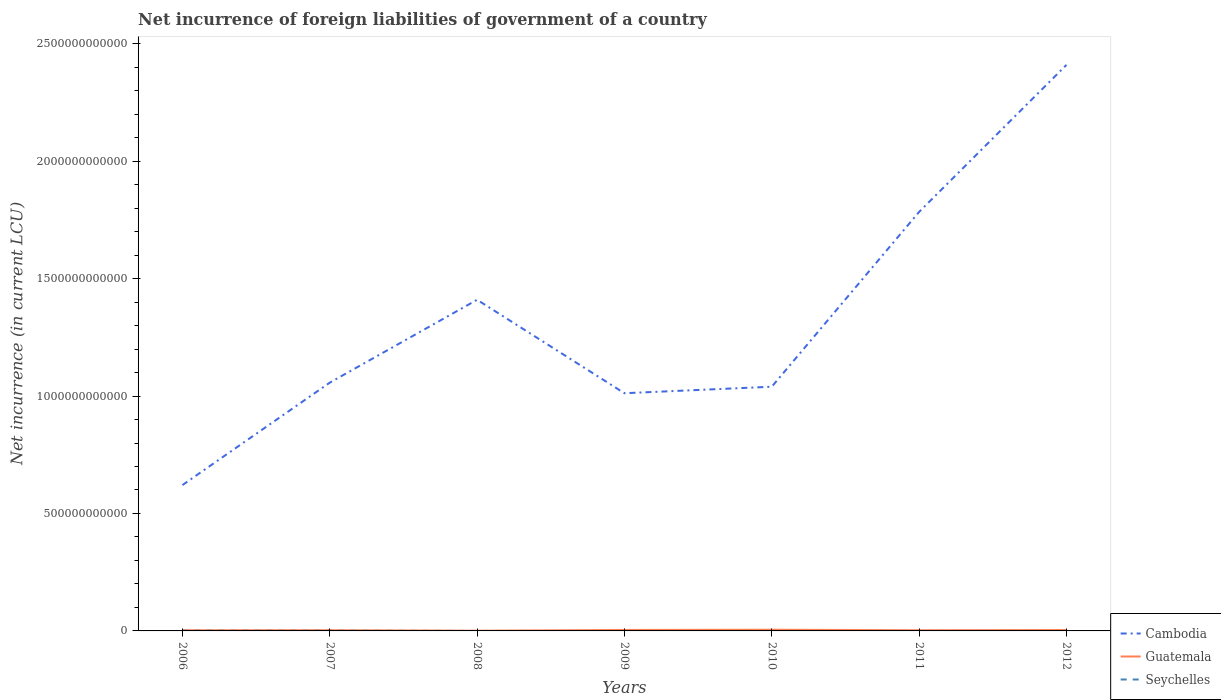How many different coloured lines are there?
Give a very brief answer. 3. Does the line corresponding to Guatemala intersect with the line corresponding to Cambodia?
Make the answer very short. No. What is the total net incurrence of foreign liabilities in Guatemala in the graph?
Give a very brief answer. -2.95e+09. What is the difference between the highest and the second highest net incurrence of foreign liabilities in Cambodia?
Give a very brief answer. 1.79e+12. What is the difference between the highest and the lowest net incurrence of foreign liabilities in Seychelles?
Your response must be concise. 2. What is the difference between two consecutive major ticks on the Y-axis?
Ensure brevity in your answer.  5.00e+11. Are the values on the major ticks of Y-axis written in scientific E-notation?
Keep it short and to the point. No. Where does the legend appear in the graph?
Your answer should be very brief. Bottom right. What is the title of the graph?
Offer a terse response. Net incurrence of foreign liabilities of government of a country. Does "Qatar" appear as one of the legend labels in the graph?
Give a very brief answer. No. What is the label or title of the X-axis?
Provide a succinct answer. Years. What is the label or title of the Y-axis?
Provide a short and direct response. Net incurrence (in current LCU). What is the Net incurrence (in current LCU) of Cambodia in 2006?
Provide a succinct answer. 6.21e+11. What is the Net incurrence (in current LCU) in Guatemala in 2006?
Provide a succinct answer. 2.87e+09. What is the Net incurrence (in current LCU) of Seychelles in 2006?
Your response must be concise. 8.78e+08. What is the Net incurrence (in current LCU) of Cambodia in 2007?
Your answer should be very brief. 1.06e+12. What is the Net incurrence (in current LCU) of Guatemala in 2007?
Offer a terse response. 3.04e+09. What is the Net incurrence (in current LCU) of Seychelles in 2007?
Your answer should be very brief. 7.25e+08. What is the Net incurrence (in current LCU) of Cambodia in 2008?
Offer a very short reply. 1.41e+12. What is the Net incurrence (in current LCU) of Guatemala in 2008?
Provide a short and direct response. 8.50e+08. What is the Net incurrence (in current LCU) of Seychelles in 2008?
Ensure brevity in your answer.  0. What is the Net incurrence (in current LCU) of Cambodia in 2009?
Keep it short and to the point. 1.01e+12. What is the Net incurrence (in current LCU) in Guatemala in 2009?
Make the answer very short. 4.12e+09. What is the Net incurrence (in current LCU) of Cambodia in 2010?
Offer a very short reply. 1.04e+12. What is the Net incurrence (in current LCU) in Guatemala in 2010?
Provide a succinct answer. 5.11e+09. What is the Net incurrence (in current LCU) of Seychelles in 2010?
Offer a very short reply. 0. What is the Net incurrence (in current LCU) of Cambodia in 2011?
Keep it short and to the point. 1.78e+12. What is the Net incurrence (in current LCU) of Guatemala in 2011?
Keep it short and to the point. 2.92e+09. What is the Net incurrence (in current LCU) of Cambodia in 2012?
Ensure brevity in your answer.  2.41e+12. What is the Net incurrence (in current LCU) of Guatemala in 2012?
Offer a terse response. 3.80e+09. Across all years, what is the maximum Net incurrence (in current LCU) of Cambodia?
Give a very brief answer. 2.41e+12. Across all years, what is the maximum Net incurrence (in current LCU) in Guatemala?
Your answer should be compact. 5.11e+09. Across all years, what is the maximum Net incurrence (in current LCU) in Seychelles?
Provide a succinct answer. 8.78e+08. Across all years, what is the minimum Net incurrence (in current LCU) in Cambodia?
Your response must be concise. 6.21e+11. Across all years, what is the minimum Net incurrence (in current LCU) in Guatemala?
Keep it short and to the point. 8.50e+08. What is the total Net incurrence (in current LCU) of Cambodia in the graph?
Provide a succinct answer. 9.33e+12. What is the total Net incurrence (in current LCU) in Guatemala in the graph?
Keep it short and to the point. 2.27e+1. What is the total Net incurrence (in current LCU) of Seychelles in the graph?
Provide a succinct answer. 1.60e+09. What is the difference between the Net incurrence (in current LCU) in Cambodia in 2006 and that in 2007?
Make the answer very short. -4.36e+11. What is the difference between the Net incurrence (in current LCU) of Guatemala in 2006 and that in 2007?
Make the answer very short. -1.74e+08. What is the difference between the Net incurrence (in current LCU) in Seychelles in 2006 and that in 2007?
Make the answer very short. 1.54e+08. What is the difference between the Net incurrence (in current LCU) of Cambodia in 2006 and that in 2008?
Offer a terse response. -7.89e+11. What is the difference between the Net incurrence (in current LCU) of Guatemala in 2006 and that in 2008?
Make the answer very short. 2.02e+09. What is the difference between the Net incurrence (in current LCU) of Cambodia in 2006 and that in 2009?
Give a very brief answer. -3.91e+11. What is the difference between the Net incurrence (in current LCU) of Guatemala in 2006 and that in 2009?
Your answer should be compact. -1.25e+09. What is the difference between the Net incurrence (in current LCU) of Cambodia in 2006 and that in 2010?
Your answer should be compact. -4.19e+11. What is the difference between the Net incurrence (in current LCU) of Guatemala in 2006 and that in 2010?
Provide a short and direct response. -2.24e+09. What is the difference between the Net incurrence (in current LCU) in Cambodia in 2006 and that in 2011?
Make the answer very short. -1.16e+12. What is the difference between the Net incurrence (in current LCU) in Guatemala in 2006 and that in 2011?
Offer a terse response. -5.65e+07. What is the difference between the Net incurrence (in current LCU) in Cambodia in 2006 and that in 2012?
Provide a short and direct response. -1.79e+12. What is the difference between the Net incurrence (in current LCU) in Guatemala in 2006 and that in 2012?
Offer a terse response. -9.31e+08. What is the difference between the Net incurrence (in current LCU) of Cambodia in 2007 and that in 2008?
Provide a short and direct response. -3.53e+11. What is the difference between the Net incurrence (in current LCU) in Guatemala in 2007 and that in 2008?
Your answer should be very brief. 2.19e+09. What is the difference between the Net incurrence (in current LCU) of Cambodia in 2007 and that in 2009?
Make the answer very short. 4.50e+1. What is the difference between the Net incurrence (in current LCU) in Guatemala in 2007 and that in 2009?
Offer a very short reply. -1.08e+09. What is the difference between the Net incurrence (in current LCU) of Cambodia in 2007 and that in 2010?
Your answer should be very brief. 1.73e+1. What is the difference between the Net incurrence (in current LCU) in Guatemala in 2007 and that in 2010?
Provide a succinct answer. -2.07e+09. What is the difference between the Net incurrence (in current LCU) in Cambodia in 2007 and that in 2011?
Make the answer very short. -7.27e+11. What is the difference between the Net incurrence (in current LCU) in Guatemala in 2007 and that in 2011?
Your response must be concise. 1.17e+08. What is the difference between the Net incurrence (in current LCU) of Cambodia in 2007 and that in 2012?
Offer a very short reply. -1.35e+12. What is the difference between the Net incurrence (in current LCU) of Guatemala in 2007 and that in 2012?
Provide a short and direct response. -7.57e+08. What is the difference between the Net incurrence (in current LCU) in Cambodia in 2008 and that in 2009?
Make the answer very short. 3.98e+11. What is the difference between the Net incurrence (in current LCU) in Guatemala in 2008 and that in 2009?
Your answer should be compact. -3.27e+09. What is the difference between the Net incurrence (in current LCU) in Cambodia in 2008 and that in 2010?
Your response must be concise. 3.70e+11. What is the difference between the Net incurrence (in current LCU) of Guatemala in 2008 and that in 2010?
Your response must be concise. -4.26e+09. What is the difference between the Net incurrence (in current LCU) of Cambodia in 2008 and that in 2011?
Provide a succinct answer. -3.74e+11. What is the difference between the Net incurrence (in current LCU) in Guatemala in 2008 and that in 2011?
Offer a terse response. -2.07e+09. What is the difference between the Net incurrence (in current LCU) in Cambodia in 2008 and that in 2012?
Provide a succinct answer. -1.00e+12. What is the difference between the Net incurrence (in current LCU) of Guatemala in 2008 and that in 2012?
Give a very brief answer. -2.95e+09. What is the difference between the Net incurrence (in current LCU) of Cambodia in 2009 and that in 2010?
Offer a very short reply. -2.77e+1. What is the difference between the Net incurrence (in current LCU) of Guatemala in 2009 and that in 2010?
Your answer should be compact. -9.92e+08. What is the difference between the Net incurrence (in current LCU) of Cambodia in 2009 and that in 2011?
Make the answer very short. -7.72e+11. What is the difference between the Net incurrence (in current LCU) of Guatemala in 2009 and that in 2011?
Your response must be concise. 1.19e+09. What is the difference between the Net incurrence (in current LCU) of Cambodia in 2009 and that in 2012?
Your answer should be compact. -1.40e+12. What is the difference between the Net incurrence (in current LCU) in Guatemala in 2009 and that in 2012?
Your response must be concise. 3.20e+08. What is the difference between the Net incurrence (in current LCU) in Cambodia in 2010 and that in 2011?
Offer a terse response. -7.44e+11. What is the difference between the Net incurrence (in current LCU) in Guatemala in 2010 and that in 2011?
Provide a succinct answer. 2.19e+09. What is the difference between the Net incurrence (in current LCU) in Cambodia in 2010 and that in 2012?
Offer a very short reply. -1.37e+12. What is the difference between the Net incurrence (in current LCU) of Guatemala in 2010 and that in 2012?
Ensure brevity in your answer.  1.31e+09. What is the difference between the Net incurrence (in current LCU) in Cambodia in 2011 and that in 2012?
Give a very brief answer. -6.26e+11. What is the difference between the Net incurrence (in current LCU) of Guatemala in 2011 and that in 2012?
Provide a succinct answer. -8.74e+08. What is the difference between the Net incurrence (in current LCU) of Cambodia in 2006 and the Net incurrence (in current LCU) of Guatemala in 2007?
Offer a terse response. 6.18e+11. What is the difference between the Net incurrence (in current LCU) in Cambodia in 2006 and the Net incurrence (in current LCU) in Seychelles in 2007?
Your response must be concise. 6.20e+11. What is the difference between the Net incurrence (in current LCU) of Guatemala in 2006 and the Net incurrence (in current LCU) of Seychelles in 2007?
Your answer should be very brief. 2.14e+09. What is the difference between the Net incurrence (in current LCU) in Cambodia in 2006 and the Net incurrence (in current LCU) in Guatemala in 2008?
Keep it short and to the point. 6.20e+11. What is the difference between the Net incurrence (in current LCU) in Cambodia in 2006 and the Net incurrence (in current LCU) in Guatemala in 2009?
Provide a short and direct response. 6.17e+11. What is the difference between the Net incurrence (in current LCU) in Cambodia in 2006 and the Net incurrence (in current LCU) in Guatemala in 2010?
Offer a very short reply. 6.16e+11. What is the difference between the Net incurrence (in current LCU) of Cambodia in 2006 and the Net incurrence (in current LCU) of Guatemala in 2011?
Offer a terse response. 6.18e+11. What is the difference between the Net incurrence (in current LCU) of Cambodia in 2006 and the Net incurrence (in current LCU) of Guatemala in 2012?
Make the answer very short. 6.17e+11. What is the difference between the Net incurrence (in current LCU) in Cambodia in 2007 and the Net incurrence (in current LCU) in Guatemala in 2008?
Offer a terse response. 1.06e+12. What is the difference between the Net incurrence (in current LCU) in Cambodia in 2007 and the Net incurrence (in current LCU) in Guatemala in 2009?
Keep it short and to the point. 1.05e+12. What is the difference between the Net incurrence (in current LCU) of Cambodia in 2007 and the Net incurrence (in current LCU) of Guatemala in 2010?
Your response must be concise. 1.05e+12. What is the difference between the Net incurrence (in current LCU) in Cambodia in 2007 and the Net incurrence (in current LCU) in Guatemala in 2011?
Ensure brevity in your answer.  1.05e+12. What is the difference between the Net incurrence (in current LCU) in Cambodia in 2007 and the Net incurrence (in current LCU) in Guatemala in 2012?
Keep it short and to the point. 1.05e+12. What is the difference between the Net incurrence (in current LCU) in Cambodia in 2008 and the Net incurrence (in current LCU) in Guatemala in 2009?
Ensure brevity in your answer.  1.41e+12. What is the difference between the Net incurrence (in current LCU) in Cambodia in 2008 and the Net incurrence (in current LCU) in Guatemala in 2010?
Give a very brief answer. 1.40e+12. What is the difference between the Net incurrence (in current LCU) of Cambodia in 2008 and the Net incurrence (in current LCU) of Guatemala in 2011?
Keep it short and to the point. 1.41e+12. What is the difference between the Net incurrence (in current LCU) in Cambodia in 2008 and the Net incurrence (in current LCU) in Guatemala in 2012?
Offer a terse response. 1.41e+12. What is the difference between the Net incurrence (in current LCU) of Cambodia in 2009 and the Net incurrence (in current LCU) of Guatemala in 2010?
Give a very brief answer. 1.01e+12. What is the difference between the Net incurrence (in current LCU) of Cambodia in 2009 and the Net incurrence (in current LCU) of Guatemala in 2011?
Your answer should be compact. 1.01e+12. What is the difference between the Net incurrence (in current LCU) of Cambodia in 2009 and the Net incurrence (in current LCU) of Guatemala in 2012?
Offer a very short reply. 1.01e+12. What is the difference between the Net incurrence (in current LCU) of Cambodia in 2010 and the Net incurrence (in current LCU) of Guatemala in 2011?
Offer a very short reply. 1.04e+12. What is the difference between the Net incurrence (in current LCU) of Cambodia in 2010 and the Net incurrence (in current LCU) of Guatemala in 2012?
Your response must be concise. 1.04e+12. What is the difference between the Net incurrence (in current LCU) of Cambodia in 2011 and the Net incurrence (in current LCU) of Guatemala in 2012?
Your response must be concise. 1.78e+12. What is the average Net incurrence (in current LCU) of Cambodia per year?
Give a very brief answer. 1.33e+12. What is the average Net incurrence (in current LCU) of Guatemala per year?
Your response must be concise. 3.24e+09. What is the average Net incurrence (in current LCU) of Seychelles per year?
Offer a very short reply. 2.29e+08. In the year 2006, what is the difference between the Net incurrence (in current LCU) in Cambodia and Net incurrence (in current LCU) in Guatemala?
Keep it short and to the point. 6.18e+11. In the year 2006, what is the difference between the Net incurrence (in current LCU) of Cambodia and Net incurrence (in current LCU) of Seychelles?
Offer a terse response. 6.20e+11. In the year 2006, what is the difference between the Net incurrence (in current LCU) of Guatemala and Net incurrence (in current LCU) of Seychelles?
Keep it short and to the point. 1.99e+09. In the year 2007, what is the difference between the Net incurrence (in current LCU) of Cambodia and Net incurrence (in current LCU) of Guatemala?
Keep it short and to the point. 1.05e+12. In the year 2007, what is the difference between the Net incurrence (in current LCU) in Cambodia and Net incurrence (in current LCU) in Seychelles?
Provide a short and direct response. 1.06e+12. In the year 2007, what is the difference between the Net incurrence (in current LCU) of Guatemala and Net incurrence (in current LCU) of Seychelles?
Your response must be concise. 2.32e+09. In the year 2008, what is the difference between the Net incurrence (in current LCU) in Cambodia and Net incurrence (in current LCU) in Guatemala?
Offer a very short reply. 1.41e+12. In the year 2009, what is the difference between the Net incurrence (in current LCU) of Cambodia and Net incurrence (in current LCU) of Guatemala?
Give a very brief answer. 1.01e+12. In the year 2010, what is the difference between the Net incurrence (in current LCU) in Cambodia and Net incurrence (in current LCU) in Guatemala?
Keep it short and to the point. 1.03e+12. In the year 2011, what is the difference between the Net incurrence (in current LCU) of Cambodia and Net incurrence (in current LCU) of Guatemala?
Your answer should be compact. 1.78e+12. In the year 2012, what is the difference between the Net incurrence (in current LCU) in Cambodia and Net incurrence (in current LCU) in Guatemala?
Your response must be concise. 2.41e+12. What is the ratio of the Net incurrence (in current LCU) of Cambodia in 2006 to that in 2007?
Provide a succinct answer. 0.59. What is the ratio of the Net incurrence (in current LCU) in Guatemala in 2006 to that in 2007?
Your answer should be compact. 0.94. What is the ratio of the Net incurrence (in current LCU) of Seychelles in 2006 to that in 2007?
Your response must be concise. 1.21. What is the ratio of the Net incurrence (in current LCU) in Cambodia in 2006 to that in 2008?
Your answer should be compact. 0.44. What is the ratio of the Net incurrence (in current LCU) in Guatemala in 2006 to that in 2008?
Make the answer very short. 3.37. What is the ratio of the Net incurrence (in current LCU) of Cambodia in 2006 to that in 2009?
Provide a short and direct response. 0.61. What is the ratio of the Net incurrence (in current LCU) in Guatemala in 2006 to that in 2009?
Make the answer very short. 0.7. What is the ratio of the Net incurrence (in current LCU) of Cambodia in 2006 to that in 2010?
Your answer should be compact. 0.6. What is the ratio of the Net incurrence (in current LCU) of Guatemala in 2006 to that in 2010?
Offer a terse response. 0.56. What is the ratio of the Net incurrence (in current LCU) in Cambodia in 2006 to that in 2011?
Your answer should be very brief. 0.35. What is the ratio of the Net incurrence (in current LCU) in Guatemala in 2006 to that in 2011?
Offer a terse response. 0.98. What is the ratio of the Net incurrence (in current LCU) in Cambodia in 2006 to that in 2012?
Make the answer very short. 0.26. What is the ratio of the Net incurrence (in current LCU) of Guatemala in 2006 to that in 2012?
Keep it short and to the point. 0.76. What is the ratio of the Net incurrence (in current LCU) in Cambodia in 2007 to that in 2008?
Ensure brevity in your answer.  0.75. What is the ratio of the Net incurrence (in current LCU) in Guatemala in 2007 to that in 2008?
Your answer should be compact. 3.58. What is the ratio of the Net incurrence (in current LCU) in Cambodia in 2007 to that in 2009?
Offer a terse response. 1.04. What is the ratio of the Net incurrence (in current LCU) of Guatemala in 2007 to that in 2009?
Give a very brief answer. 0.74. What is the ratio of the Net incurrence (in current LCU) of Cambodia in 2007 to that in 2010?
Make the answer very short. 1.02. What is the ratio of the Net incurrence (in current LCU) of Guatemala in 2007 to that in 2010?
Your response must be concise. 0.59. What is the ratio of the Net incurrence (in current LCU) in Cambodia in 2007 to that in 2011?
Provide a succinct answer. 0.59. What is the ratio of the Net incurrence (in current LCU) of Cambodia in 2007 to that in 2012?
Your response must be concise. 0.44. What is the ratio of the Net incurrence (in current LCU) of Guatemala in 2007 to that in 2012?
Your answer should be very brief. 0.8. What is the ratio of the Net incurrence (in current LCU) in Cambodia in 2008 to that in 2009?
Keep it short and to the point. 1.39. What is the ratio of the Net incurrence (in current LCU) of Guatemala in 2008 to that in 2009?
Keep it short and to the point. 0.21. What is the ratio of the Net incurrence (in current LCU) in Cambodia in 2008 to that in 2010?
Provide a succinct answer. 1.36. What is the ratio of the Net incurrence (in current LCU) in Guatemala in 2008 to that in 2010?
Provide a succinct answer. 0.17. What is the ratio of the Net incurrence (in current LCU) in Cambodia in 2008 to that in 2011?
Provide a succinct answer. 0.79. What is the ratio of the Net incurrence (in current LCU) of Guatemala in 2008 to that in 2011?
Provide a succinct answer. 0.29. What is the ratio of the Net incurrence (in current LCU) of Cambodia in 2008 to that in 2012?
Give a very brief answer. 0.58. What is the ratio of the Net incurrence (in current LCU) in Guatemala in 2008 to that in 2012?
Ensure brevity in your answer.  0.22. What is the ratio of the Net incurrence (in current LCU) in Cambodia in 2009 to that in 2010?
Your response must be concise. 0.97. What is the ratio of the Net incurrence (in current LCU) of Guatemala in 2009 to that in 2010?
Make the answer very short. 0.81. What is the ratio of the Net incurrence (in current LCU) in Cambodia in 2009 to that in 2011?
Your response must be concise. 0.57. What is the ratio of the Net incurrence (in current LCU) in Guatemala in 2009 to that in 2011?
Provide a short and direct response. 1.41. What is the ratio of the Net incurrence (in current LCU) of Cambodia in 2009 to that in 2012?
Give a very brief answer. 0.42. What is the ratio of the Net incurrence (in current LCU) of Guatemala in 2009 to that in 2012?
Your answer should be compact. 1.08. What is the ratio of the Net incurrence (in current LCU) in Cambodia in 2010 to that in 2011?
Your answer should be very brief. 0.58. What is the ratio of the Net incurrence (in current LCU) in Guatemala in 2010 to that in 2011?
Provide a short and direct response. 1.75. What is the ratio of the Net incurrence (in current LCU) in Cambodia in 2010 to that in 2012?
Your answer should be compact. 0.43. What is the ratio of the Net incurrence (in current LCU) of Guatemala in 2010 to that in 2012?
Provide a short and direct response. 1.35. What is the ratio of the Net incurrence (in current LCU) in Cambodia in 2011 to that in 2012?
Your response must be concise. 0.74. What is the ratio of the Net incurrence (in current LCU) in Guatemala in 2011 to that in 2012?
Offer a very short reply. 0.77. What is the difference between the highest and the second highest Net incurrence (in current LCU) of Cambodia?
Offer a terse response. 6.26e+11. What is the difference between the highest and the second highest Net incurrence (in current LCU) of Guatemala?
Your answer should be very brief. 9.92e+08. What is the difference between the highest and the lowest Net incurrence (in current LCU) in Cambodia?
Keep it short and to the point. 1.79e+12. What is the difference between the highest and the lowest Net incurrence (in current LCU) in Guatemala?
Keep it short and to the point. 4.26e+09. What is the difference between the highest and the lowest Net incurrence (in current LCU) of Seychelles?
Provide a short and direct response. 8.78e+08. 